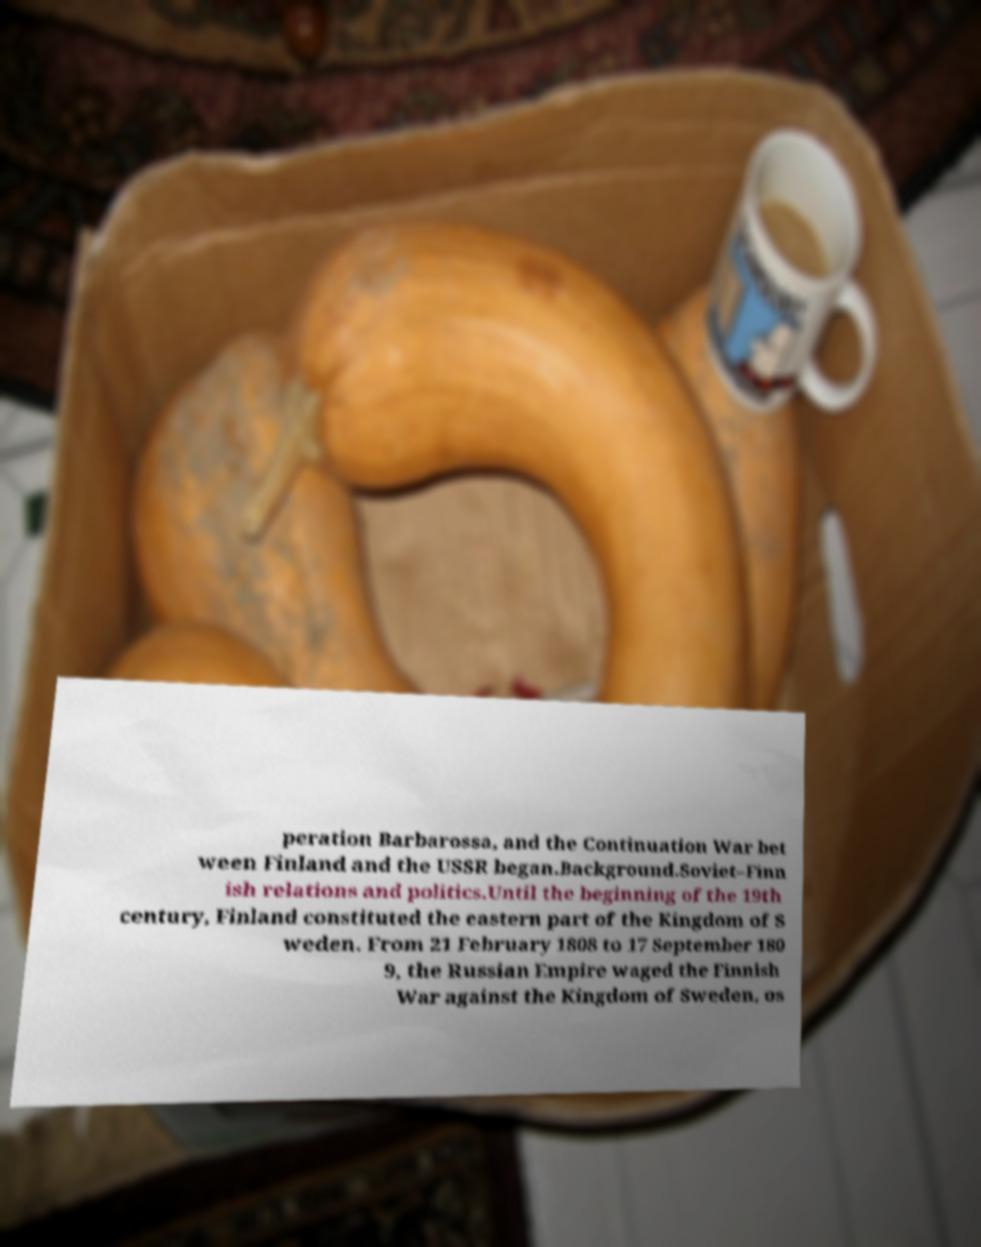Please read and relay the text visible in this image. What does it say? peration Barbarossa, and the Continuation War bet ween Finland and the USSR began.Background.Soviet–Finn ish relations and politics.Until the beginning of the 19th century, Finland constituted the eastern part of the Kingdom of S weden. From 21 February 1808 to 17 September 180 9, the Russian Empire waged the Finnish War against the Kingdom of Sweden, os 